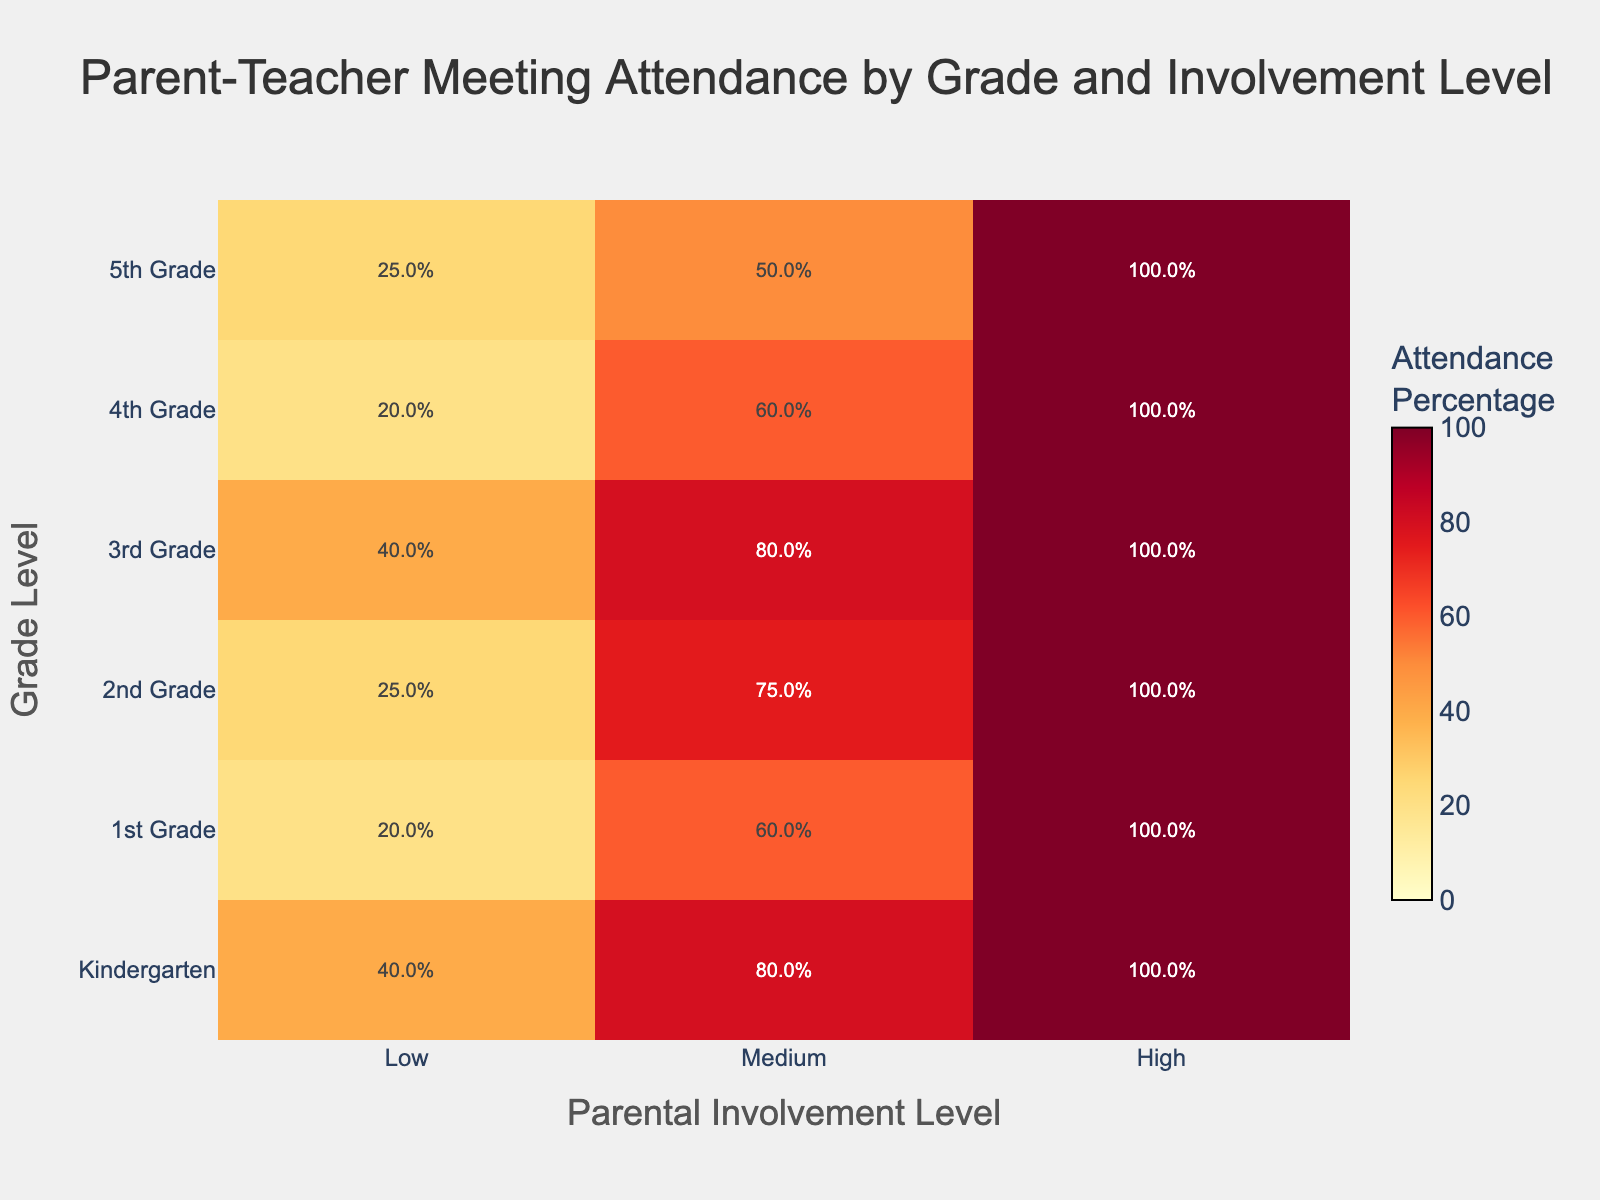What is the title of the heatmap? The title is usually found at the top of the heatmap and provides a succinct description of the data being visualized. In this case, it indicates the focus on attendance in parent-teacher meetings by grade and parental involvement level.
Answer: "Parent-Teacher Meeting Attendance by Grade and Involvement Level" What are the labels on the y-axis? The y-axis labels denote the different grade levels for which the attendance data is plotted. Each label corresponds to a row in the heatmap.
Answer: Kindergarten, 1st Grade, 2nd Grade, 3rd Grade, 4th Grade, 5th Grade Which grade and parental involvement combination has the highest attendance percentage? We need to identify the cell with the darkest red color, which represents the highest attendance percentage. Darker colors in the heatmap indicate higher values. The percentages are also explicitly printed on each cell.
Answer: Kindergarten and High (100%) For 3rd Grade, how does attendance change with different parental involvement levels? By examining the row corresponding to 3rd Grade, we can compare the values of attendance percentages for different involvement levels: Low, Medium, and High.
Answer: It's 40%, 80%, and 100% respectively What is the overall trend you observe as parental involvement increases for any given grade level? To identify this trend, we should look at how the color transition occurs from Low to High involvement for each grade level across the rows. Generally, we should see an increase in the darkness of the color as we move from Low to High involvement.
Answer: Attendance increases Identify a grade level where the attendance percentage is less than 50% for Low parental involvement? By scanning through the rows corresponding to Low parental involvement across all grades, we look for cells with a percentage less than 50%.
Answer: 1st Grade, 2nd Grade, 4th Grade, 5th Grade What's the total number of meetings attended by Kindergarten students with Medium parental involvement? From the given data, look at the entry for Kindergarten and Medium involvement in terms of the number of meetings attended.
Answer: 4 Which grade level has the lowest attendance percentage with Low parental involvement, and what is the percentage? Locate the row with the lowest value in the 'Low' column. The corresponding cell will give us the necessary information.
Answer: 1st Grade and 2nd Grade (20%) Which grade level shows the least variation in attendance percentage across different parental involvement levels? To determine the variation, we look at the attendance percentages for each grade and calculate the range. The grade with the smallest range has the least variation.
Answer: 2nd Grade (25% - 100%) How does the attendance percentage for 5th Grade with Medium involvement compare to that of 3rd Grade with Medium involvement? Compare the attendance percentage values in the 'Medium' column for both 5th Grade and 3rd Grade to determine the difference.
Answer: 5th Grade is 50% and 3rd Grade is 80%, so 3rd Grade is higher 